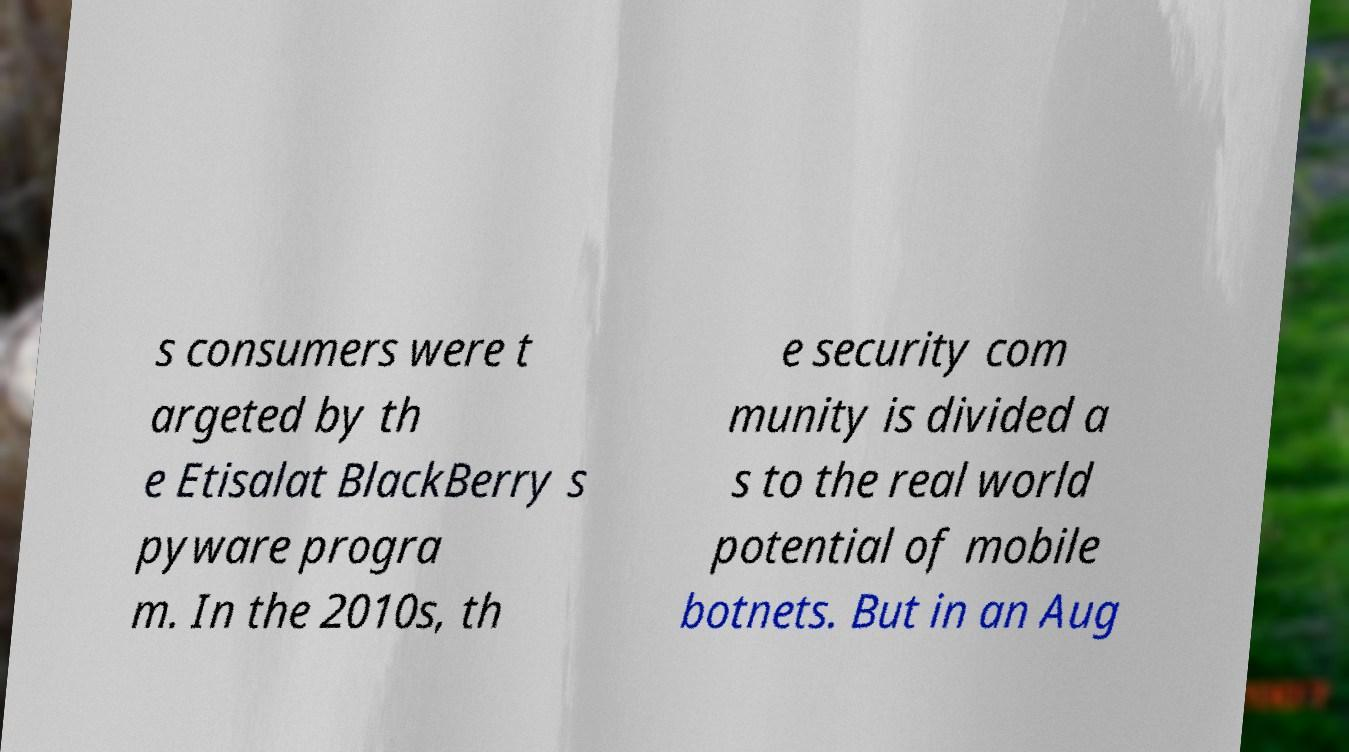Please read and relay the text visible in this image. What does it say? s consumers were t argeted by th e Etisalat BlackBerry s pyware progra m. In the 2010s, th e security com munity is divided a s to the real world potential of mobile botnets. But in an Aug 